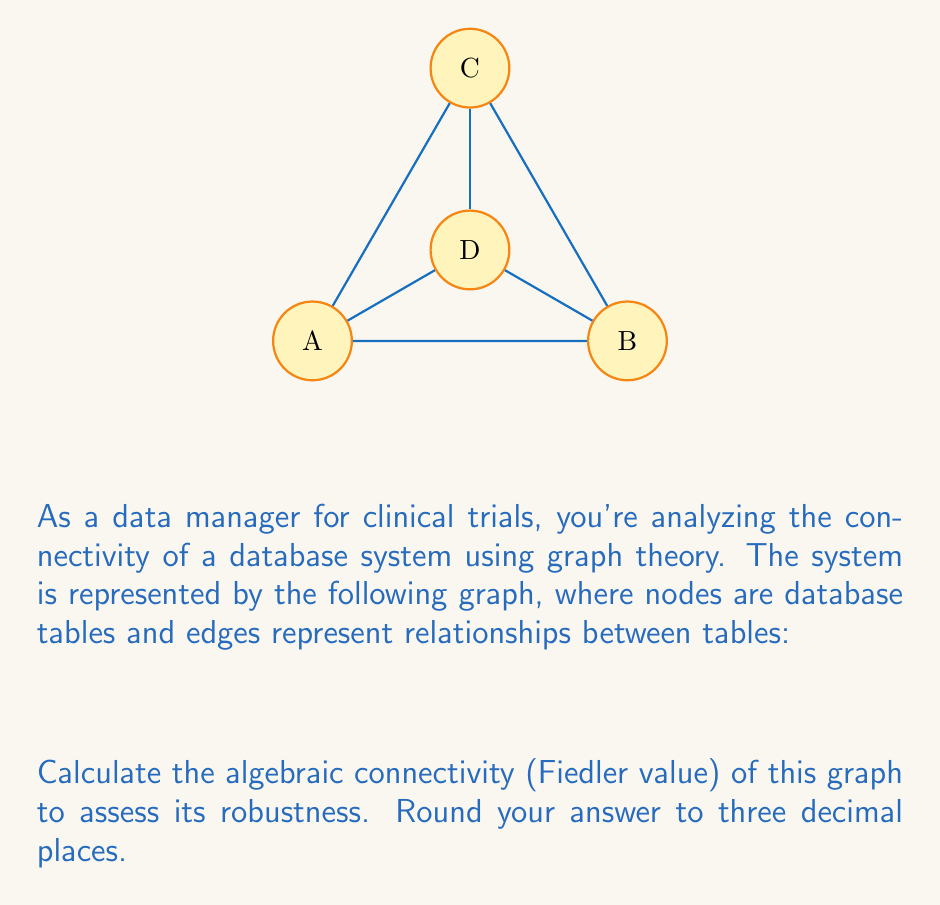Show me your answer to this math problem. To find the algebraic connectivity (Fiedler value) of the graph, we need to follow these steps:

1) First, construct the Laplacian matrix $L$ of the graph:
   $L = D - A$, where $D$ is the degree matrix and $A$ is the adjacency matrix.

2) The adjacency matrix $A$ for this graph is:
   $$A = \begin{bmatrix}
   0 & 1 & 1 & 1 \\
   1 & 0 & 1 & 1 \\
   1 & 1 & 0 & 1 \\
   1 & 1 & 1 & 0
   \end{bmatrix}$$

3) The degree matrix $D$ is:
   $$D = \begin{bmatrix}
   3 & 0 & 0 & 0 \\
   0 & 3 & 0 & 0 \\
   0 & 0 & 3 & 0 \\
   0 & 0 & 0 & 3
   \end{bmatrix}$$

4) Now, we can calculate the Laplacian matrix $L$:
   $$L = D - A = \begin{bmatrix}
   3 & -1 & -1 & -1 \\
   -1 & 3 & -1 & -1 \\
   -1 & -1 & 3 & -1 \\
   -1 & -1 & -1 & 3
   \end{bmatrix}$$

5) The eigenvalues of $L$ are: $\lambda_1 = 0, \lambda_2 = 4, \lambda_3 = 4, \lambda_4 = 4$

6) The algebraic connectivity (Fiedler value) is the second smallest eigenvalue.

Therefore, the Fiedler value is 4.000 (rounded to three decimal places).

This high Fiedler value indicates that the graph (and thus the database system) has strong connectivity and is robust against potential disconnections.
Answer: 4.000 